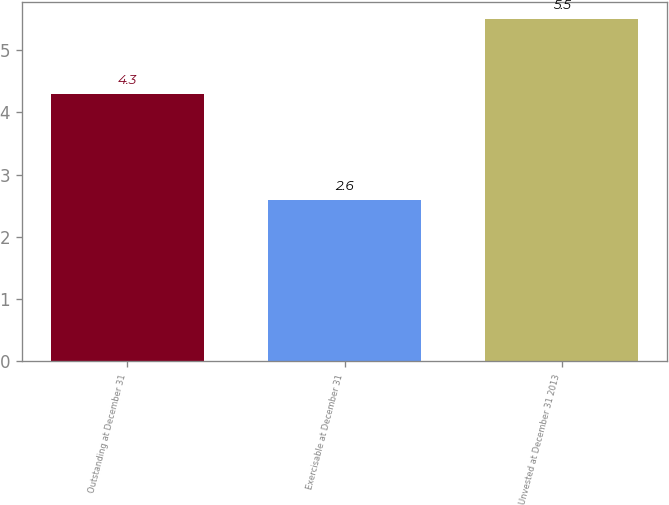<chart> <loc_0><loc_0><loc_500><loc_500><bar_chart><fcel>Outstanding at December 31<fcel>Exercisable at December 31<fcel>Unvested at December 31 2013<nl><fcel>4.3<fcel>2.6<fcel>5.5<nl></chart> 